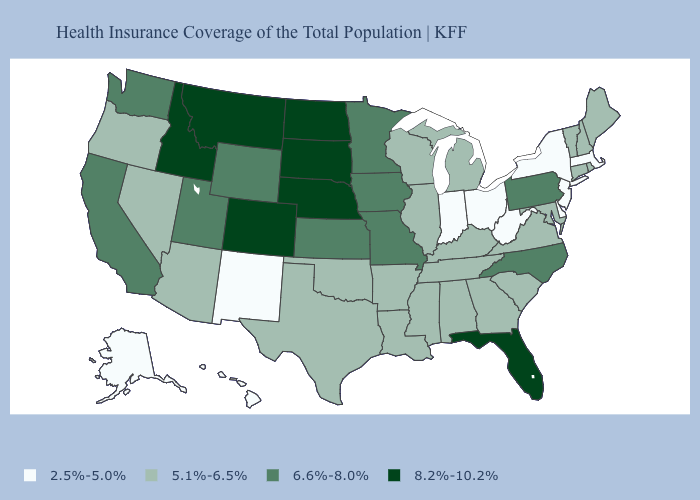Which states have the lowest value in the USA?
Write a very short answer. Alaska, Delaware, Hawaii, Indiana, Massachusetts, New Jersey, New Mexico, New York, Ohio, West Virginia. What is the highest value in states that border South Dakota?
Concise answer only. 8.2%-10.2%. Which states have the lowest value in the USA?
Concise answer only. Alaska, Delaware, Hawaii, Indiana, Massachusetts, New Jersey, New Mexico, New York, Ohio, West Virginia. Does South Dakota have the highest value in the USA?
Short answer required. Yes. Name the states that have a value in the range 5.1%-6.5%?
Write a very short answer. Alabama, Arizona, Arkansas, Connecticut, Georgia, Illinois, Kentucky, Louisiana, Maine, Maryland, Michigan, Mississippi, Nevada, New Hampshire, Oklahoma, Oregon, Rhode Island, South Carolina, Tennessee, Texas, Vermont, Virginia, Wisconsin. How many symbols are there in the legend?
Answer briefly. 4. What is the highest value in the MidWest ?
Give a very brief answer. 8.2%-10.2%. Name the states that have a value in the range 8.2%-10.2%?
Answer briefly. Colorado, Florida, Idaho, Montana, Nebraska, North Dakota, South Dakota. Does Pennsylvania have the highest value in the Northeast?
Answer briefly. Yes. What is the highest value in the USA?
Concise answer only. 8.2%-10.2%. Does Idaho have a higher value than South Carolina?
Give a very brief answer. Yes. Which states have the highest value in the USA?
Answer briefly. Colorado, Florida, Idaho, Montana, Nebraska, North Dakota, South Dakota. Does Vermont have a lower value than Rhode Island?
Write a very short answer. No. What is the value of Indiana?
Give a very brief answer. 2.5%-5.0%. What is the value of North Carolina?
Answer briefly. 6.6%-8.0%. 